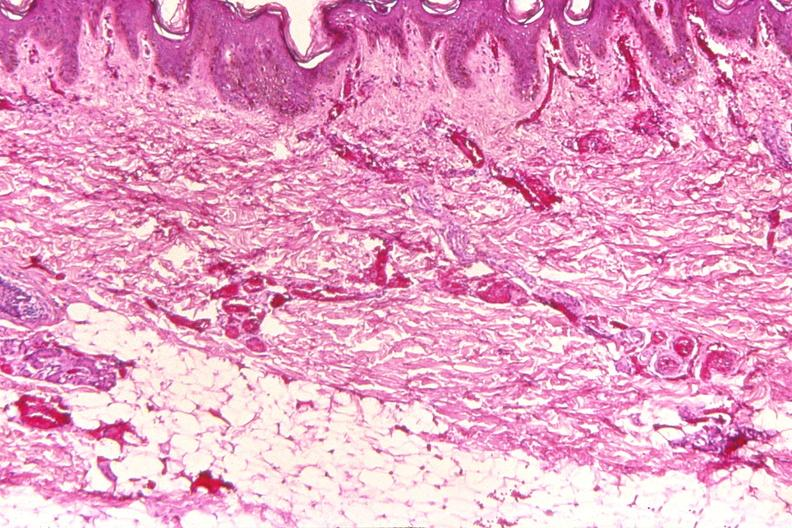does this partially fixed gross show skin, petechial hemorrhages from patient with meningococcemia?
Answer the question using a single word or phrase. No 